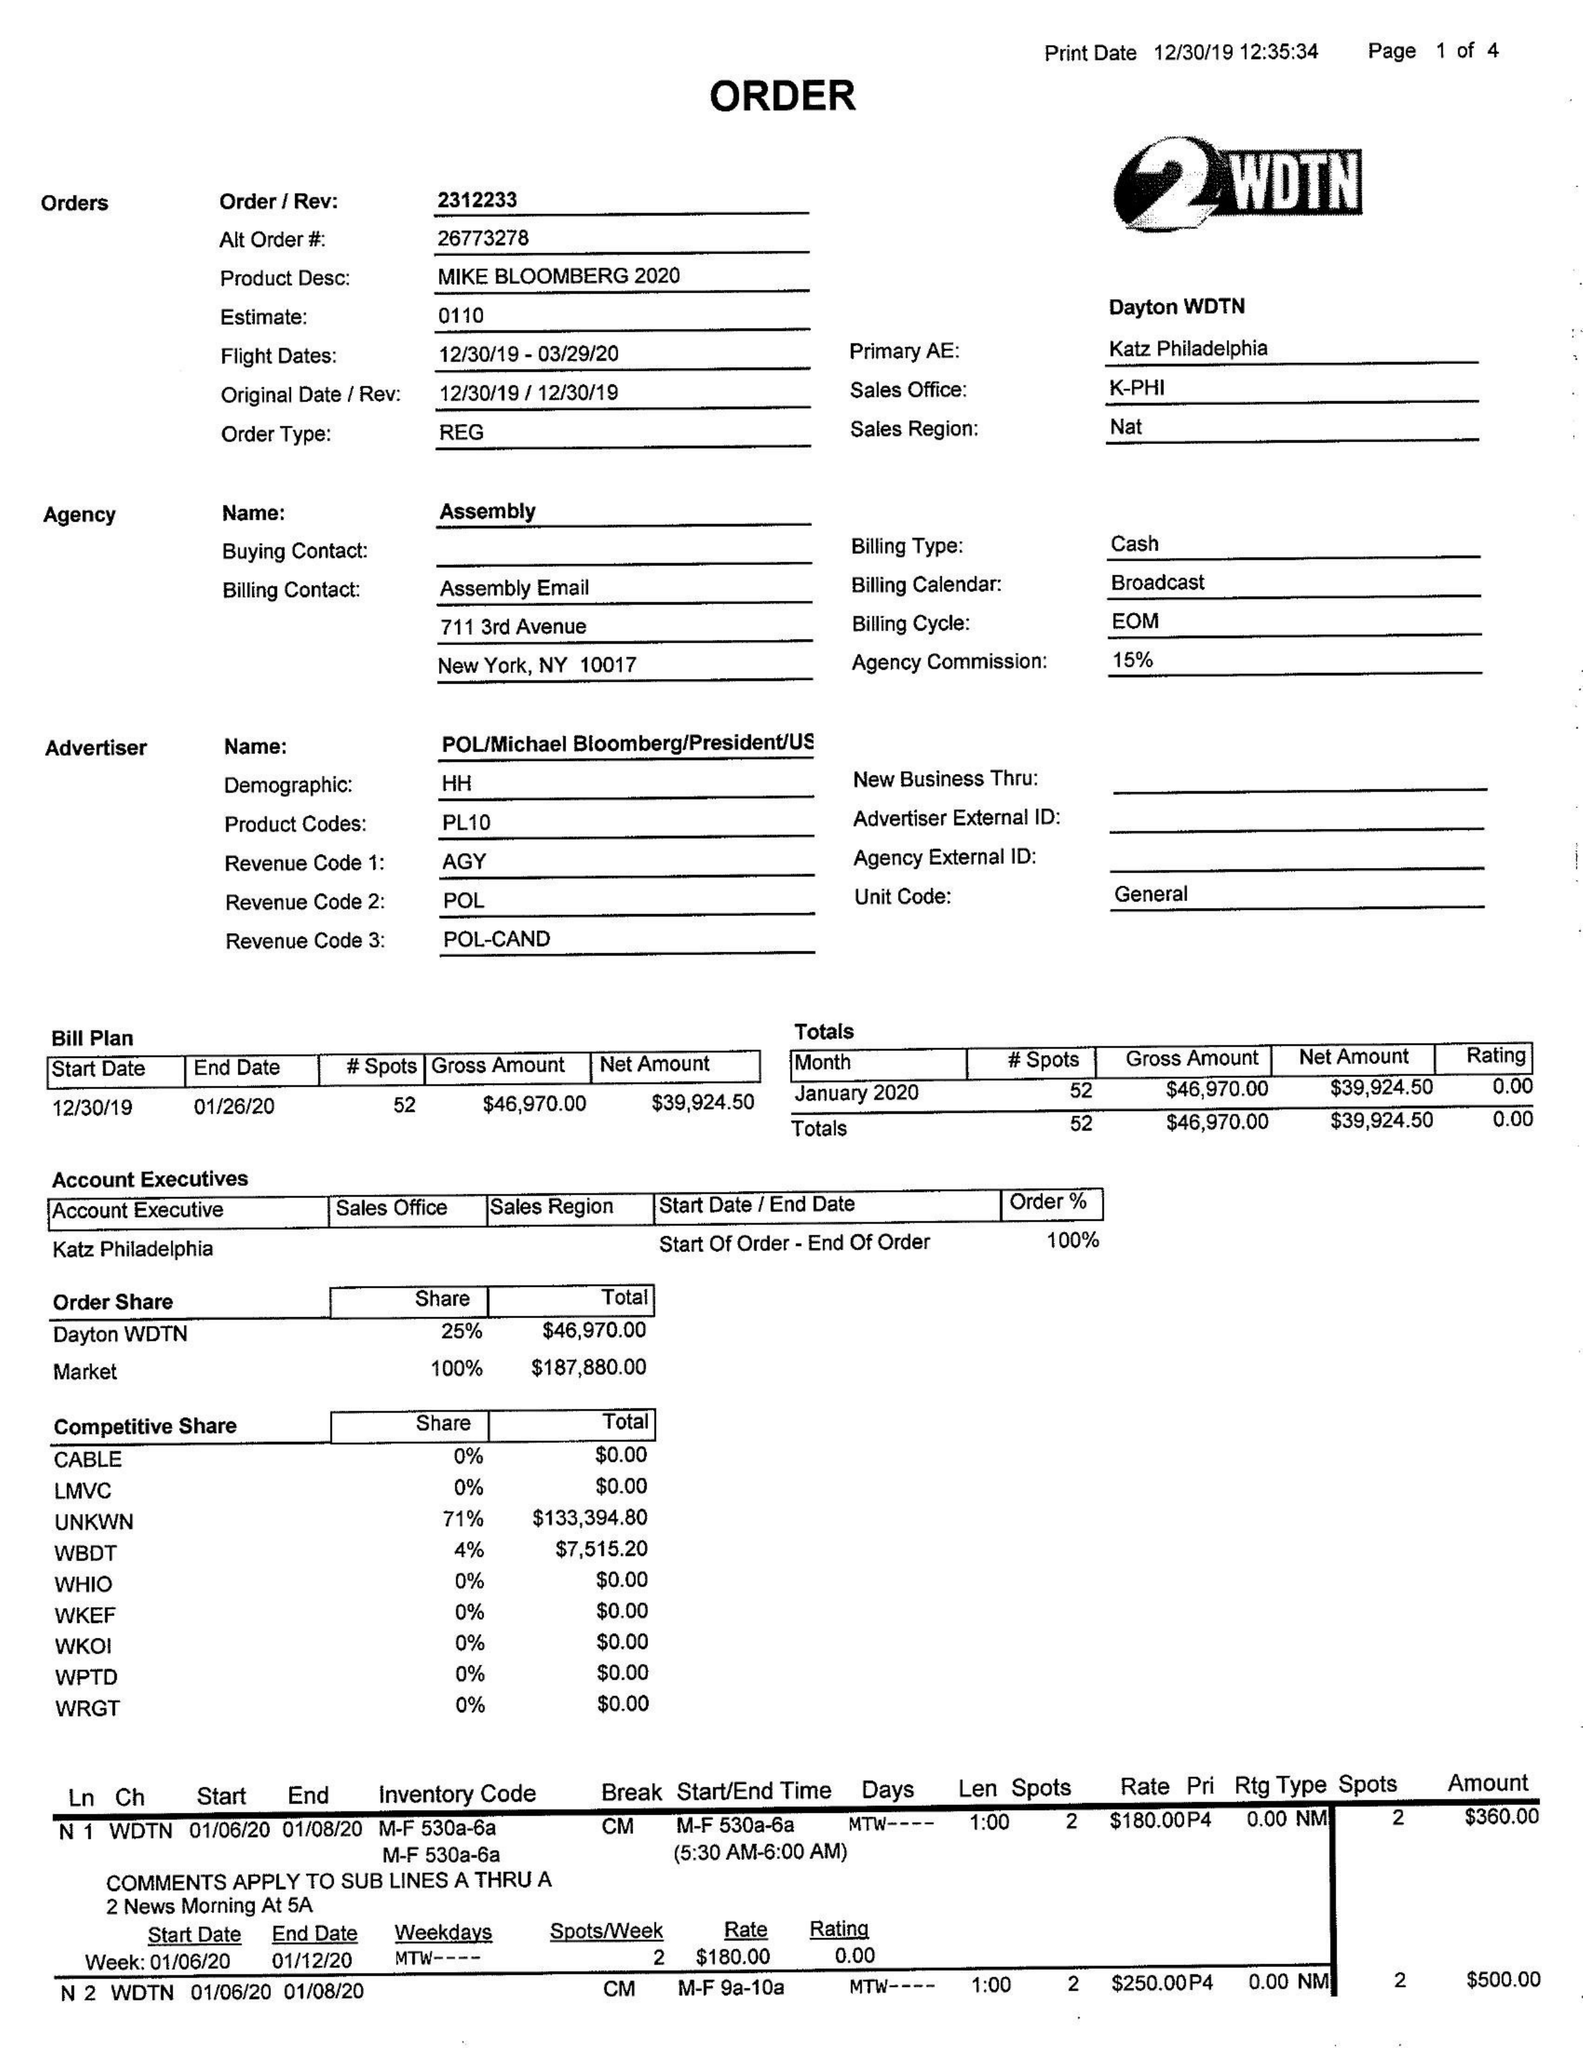What is the value for the flight_to?
Answer the question using a single word or phrase. 03/29/20 